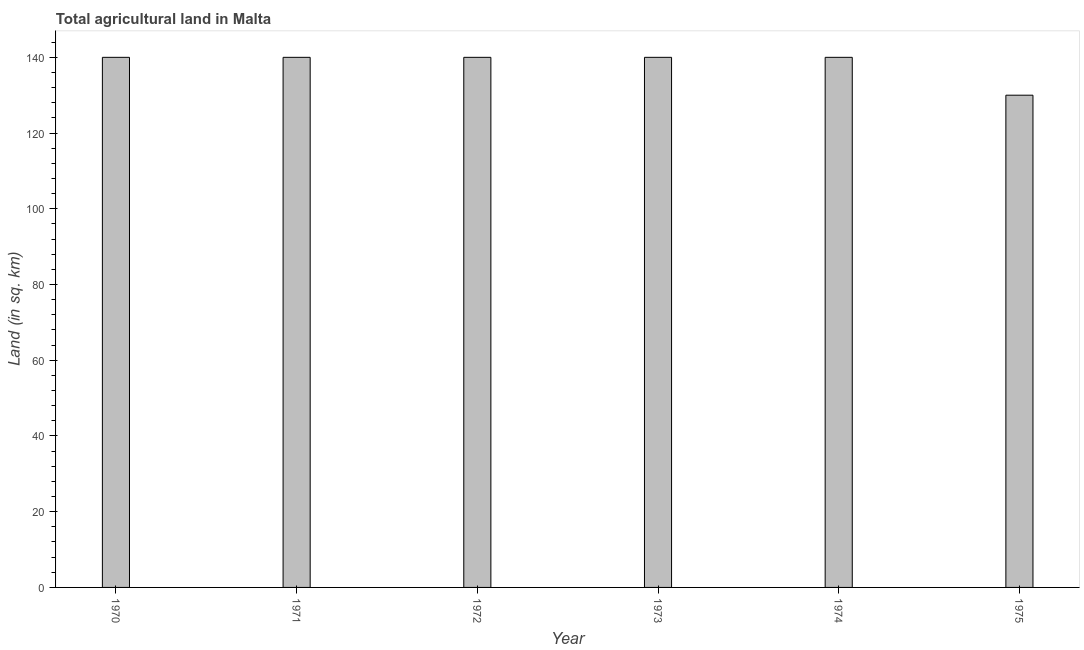Does the graph contain grids?
Provide a succinct answer. No. What is the title of the graph?
Provide a succinct answer. Total agricultural land in Malta. What is the label or title of the X-axis?
Your answer should be very brief. Year. What is the label or title of the Y-axis?
Ensure brevity in your answer.  Land (in sq. km). What is the agricultural land in 1975?
Provide a succinct answer. 130. Across all years, what is the maximum agricultural land?
Give a very brief answer. 140. Across all years, what is the minimum agricultural land?
Make the answer very short. 130. In which year was the agricultural land maximum?
Ensure brevity in your answer.  1970. In which year was the agricultural land minimum?
Offer a terse response. 1975. What is the sum of the agricultural land?
Your response must be concise. 830. What is the average agricultural land per year?
Your answer should be very brief. 138.33. What is the median agricultural land?
Offer a terse response. 140. What is the ratio of the agricultural land in 1970 to that in 1975?
Your answer should be very brief. 1.08. Is the difference between the agricultural land in 1974 and 1975 greater than the difference between any two years?
Provide a succinct answer. Yes. What is the difference between the highest and the second highest agricultural land?
Give a very brief answer. 0. Is the sum of the agricultural land in 1973 and 1975 greater than the maximum agricultural land across all years?
Provide a succinct answer. Yes. What is the difference between the highest and the lowest agricultural land?
Ensure brevity in your answer.  10. In how many years, is the agricultural land greater than the average agricultural land taken over all years?
Give a very brief answer. 5. How many bars are there?
Offer a terse response. 6. How many years are there in the graph?
Your answer should be very brief. 6. What is the difference between two consecutive major ticks on the Y-axis?
Your response must be concise. 20. What is the Land (in sq. km) in 1970?
Keep it short and to the point. 140. What is the Land (in sq. km) in 1971?
Your response must be concise. 140. What is the Land (in sq. km) in 1972?
Give a very brief answer. 140. What is the Land (in sq. km) of 1973?
Your response must be concise. 140. What is the Land (in sq. km) of 1974?
Offer a terse response. 140. What is the Land (in sq. km) in 1975?
Provide a short and direct response. 130. What is the difference between the Land (in sq. km) in 1970 and 1972?
Provide a succinct answer. 0. What is the difference between the Land (in sq. km) in 1970 and 1973?
Make the answer very short. 0. What is the difference between the Land (in sq. km) in 1970 and 1974?
Your answer should be very brief. 0. What is the difference between the Land (in sq. km) in 1970 and 1975?
Make the answer very short. 10. What is the difference between the Land (in sq. km) in 1971 and 1974?
Keep it short and to the point. 0. What is the difference between the Land (in sq. km) in 1972 and 1975?
Keep it short and to the point. 10. What is the difference between the Land (in sq. km) in 1974 and 1975?
Offer a terse response. 10. What is the ratio of the Land (in sq. km) in 1970 to that in 1971?
Provide a short and direct response. 1. What is the ratio of the Land (in sq. km) in 1970 to that in 1973?
Your answer should be very brief. 1. What is the ratio of the Land (in sq. km) in 1970 to that in 1975?
Offer a terse response. 1.08. What is the ratio of the Land (in sq. km) in 1971 to that in 1972?
Give a very brief answer. 1. What is the ratio of the Land (in sq. km) in 1971 to that in 1973?
Give a very brief answer. 1. What is the ratio of the Land (in sq. km) in 1971 to that in 1975?
Make the answer very short. 1.08. What is the ratio of the Land (in sq. km) in 1972 to that in 1975?
Your answer should be compact. 1.08. What is the ratio of the Land (in sq. km) in 1973 to that in 1975?
Your answer should be very brief. 1.08. What is the ratio of the Land (in sq. km) in 1974 to that in 1975?
Your answer should be very brief. 1.08. 